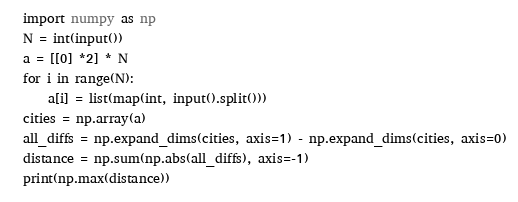<code> <loc_0><loc_0><loc_500><loc_500><_Python_>import numpy as np
N = int(input())
a = [[0] *2] * N
for i in range(N):
    a[i] = list(map(int, input().split()))
cities = np.array(a)
all_diffs = np.expand_dims(cities, axis=1) - np.expand_dims(cities, axis=0)
distance = np.sum(np.abs(all_diffs), axis=-1)
print(np.max(distance))</code> 